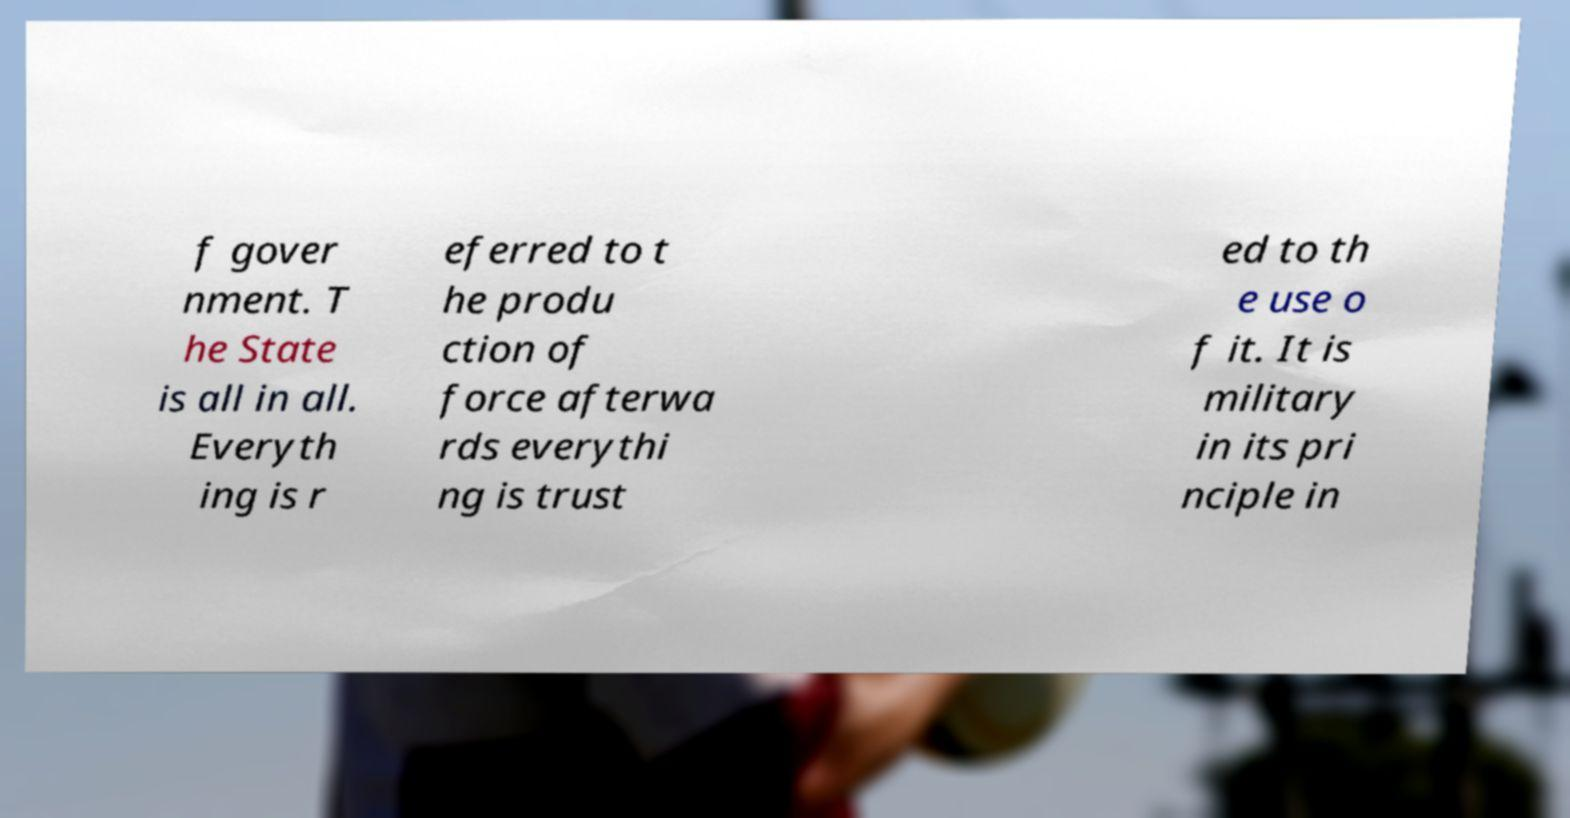Could you extract and type out the text from this image? f gover nment. T he State is all in all. Everyth ing is r eferred to t he produ ction of force afterwa rds everythi ng is trust ed to th e use o f it. It is military in its pri nciple in 